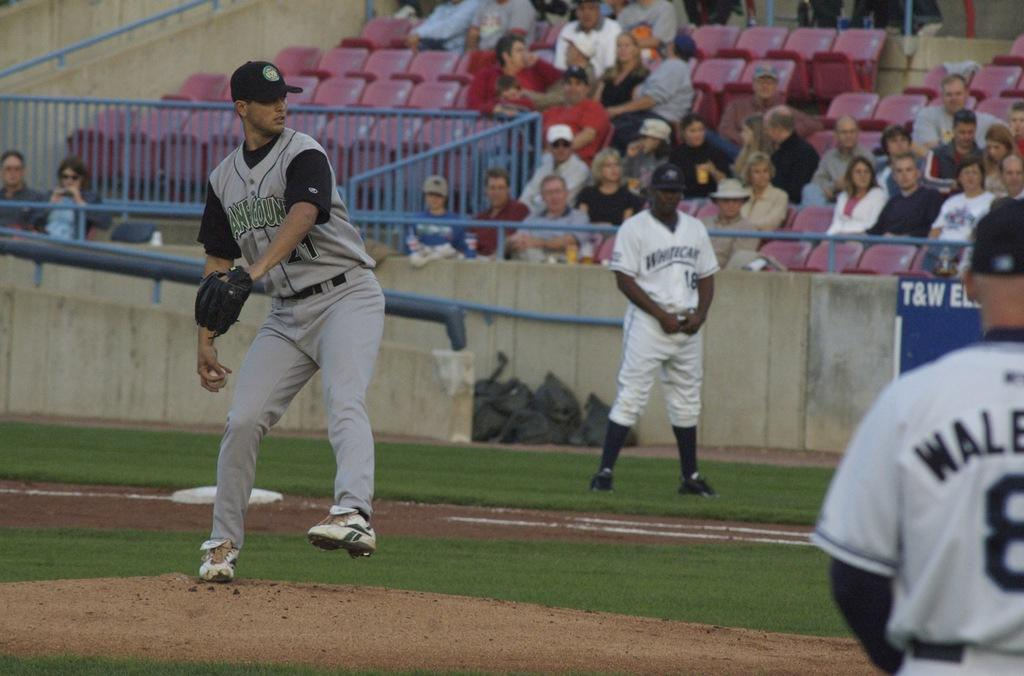<image>
Present a compact description of the photo's key features. Player 21 of a baseball team is about to throw the ball while players 18 and 8 stand in the background. 